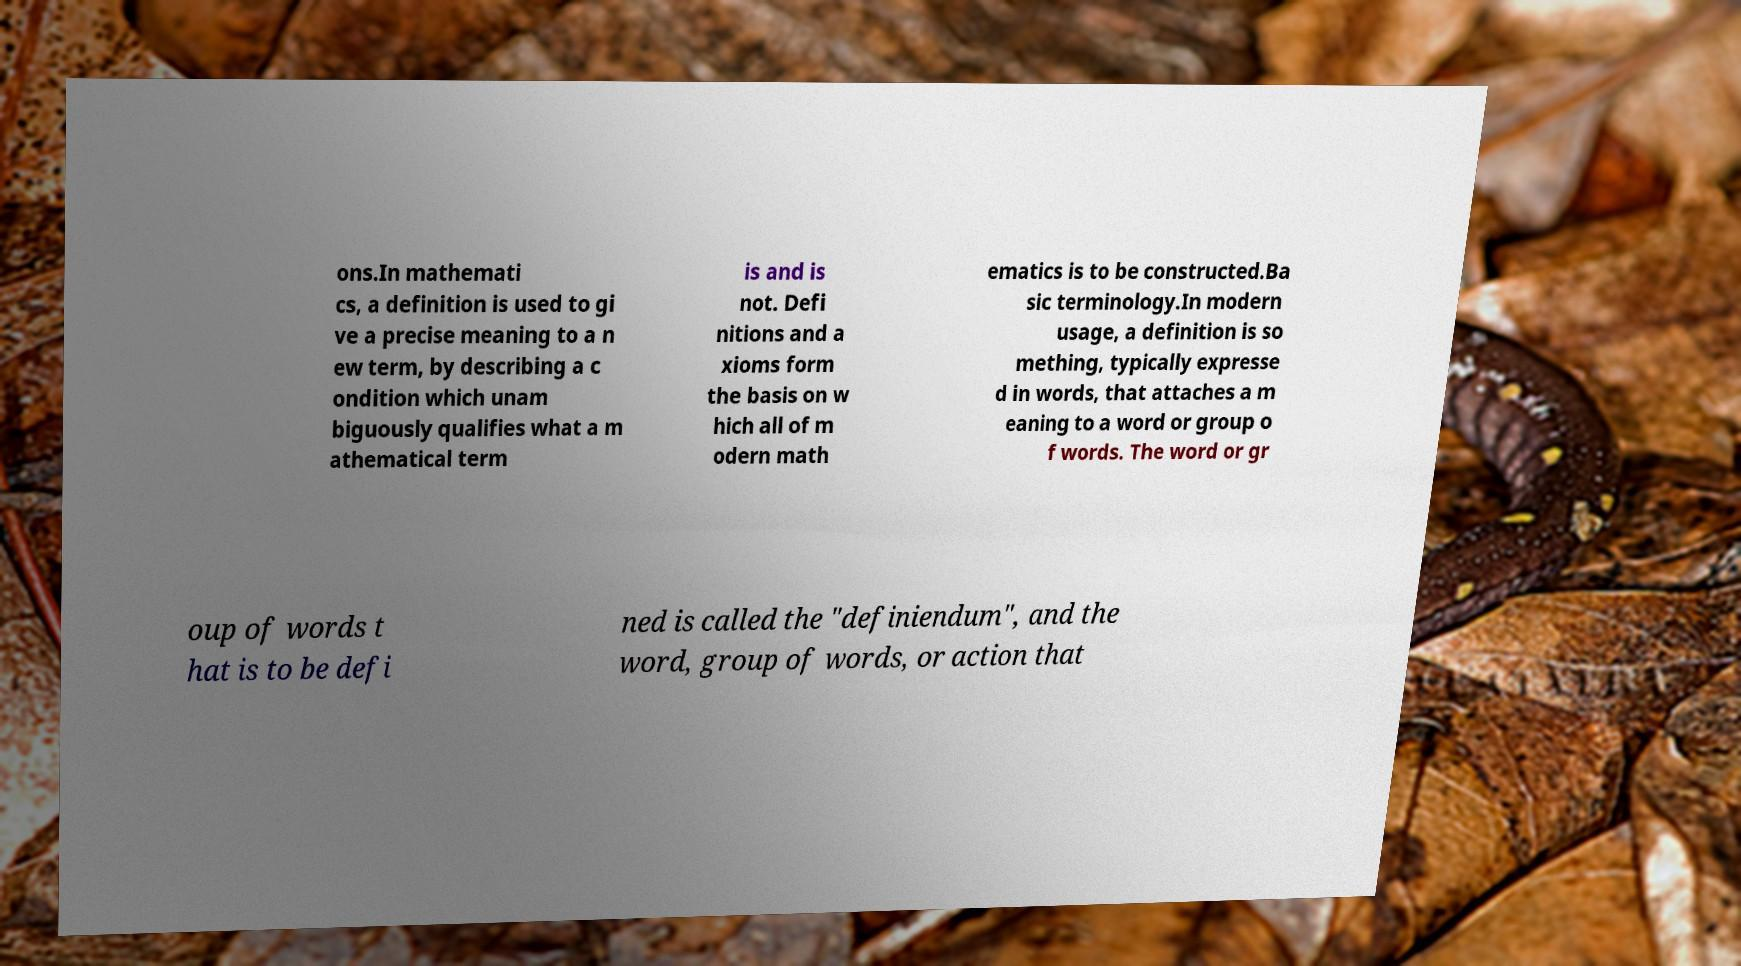Please identify and transcribe the text found in this image. ons.In mathemati cs, a definition is used to gi ve a precise meaning to a n ew term, by describing a c ondition which unam biguously qualifies what a m athematical term is and is not. Defi nitions and a xioms form the basis on w hich all of m odern math ematics is to be constructed.Ba sic terminology.In modern usage, a definition is so mething, typically expresse d in words, that attaches a m eaning to a word or group o f words. The word or gr oup of words t hat is to be defi ned is called the "definiendum", and the word, group of words, or action that 